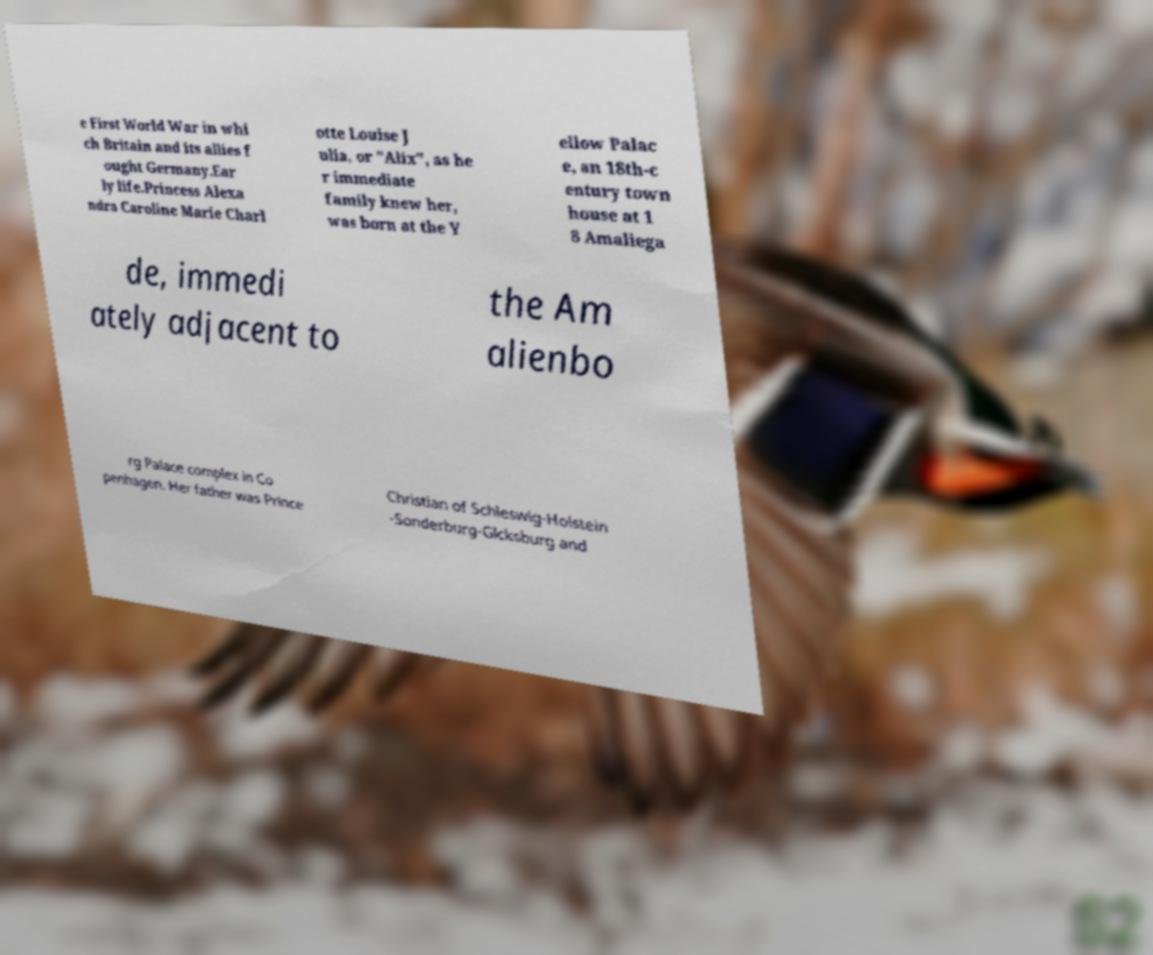Please identify and transcribe the text found in this image. e First World War in whi ch Britain and its allies f ought Germany.Ear ly life.Princess Alexa ndra Caroline Marie Charl otte Louise J ulia, or "Alix", as he r immediate family knew her, was born at the Y ellow Palac e, an 18th-c entury town house at 1 8 Amaliega de, immedi ately adjacent to the Am alienbo rg Palace complex in Co penhagen. Her father was Prince Christian of Schleswig-Holstein -Sonderburg-Glcksburg and 